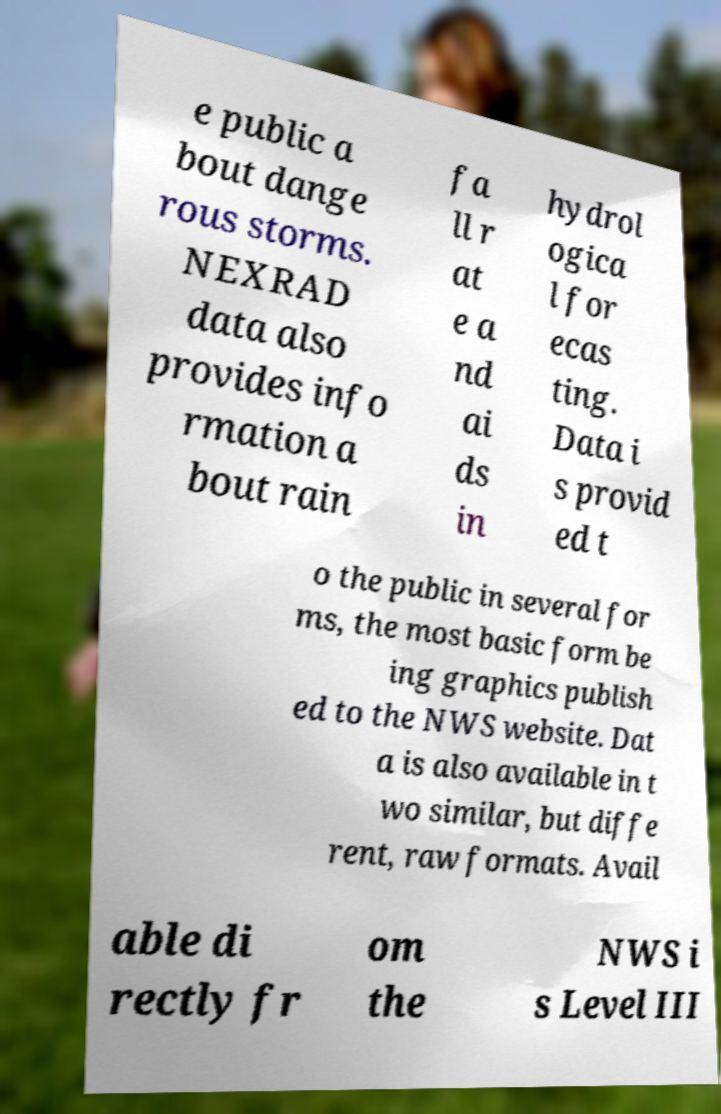Can you accurately transcribe the text from the provided image for me? e public a bout dange rous storms. NEXRAD data also provides info rmation a bout rain fa ll r at e a nd ai ds in hydrol ogica l for ecas ting. Data i s provid ed t o the public in several for ms, the most basic form be ing graphics publish ed to the NWS website. Dat a is also available in t wo similar, but diffe rent, raw formats. Avail able di rectly fr om the NWS i s Level III 